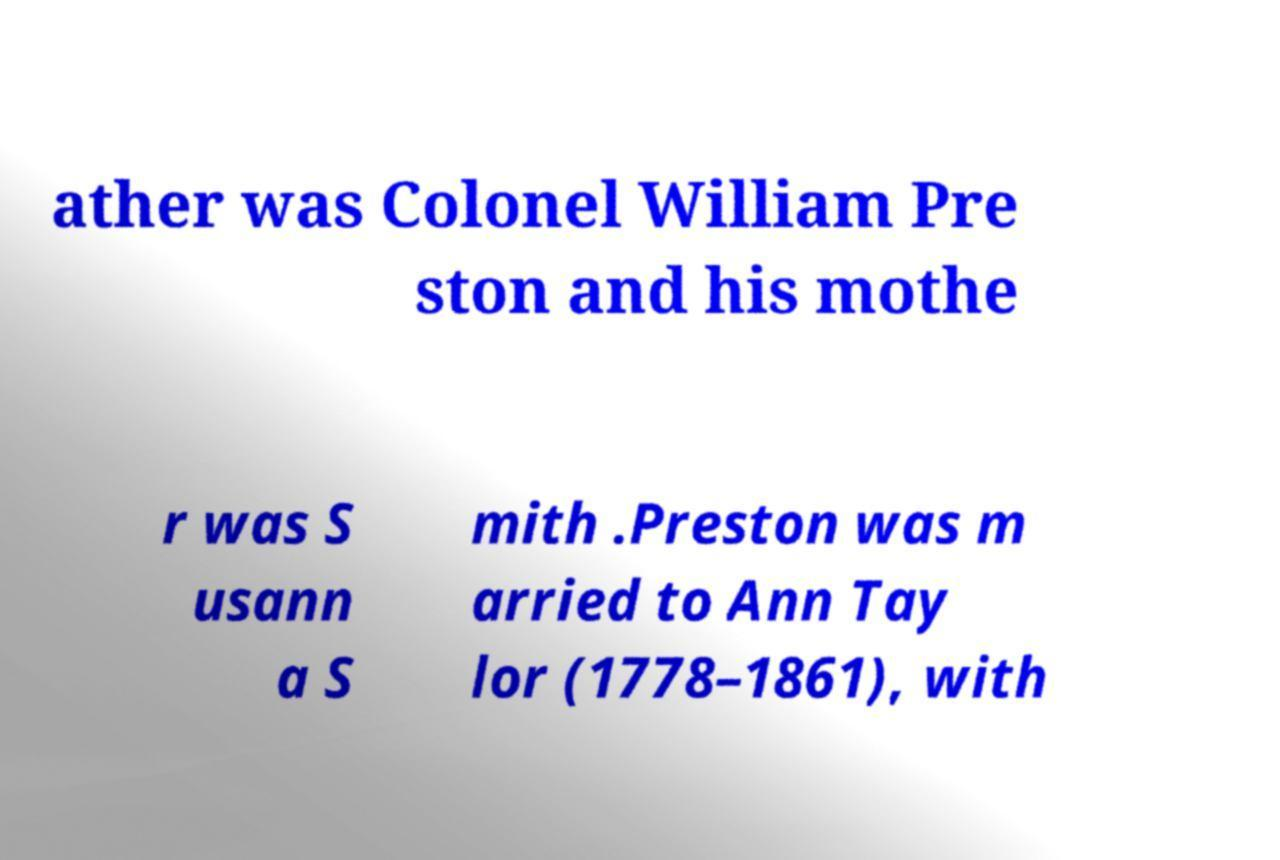Please read and relay the text visible in this image. What does it say? ather was Colonel William Pre ston and his mothe r was S usann a S mith .Preston was m arried to Ann Tay lor (1778–1861), with 